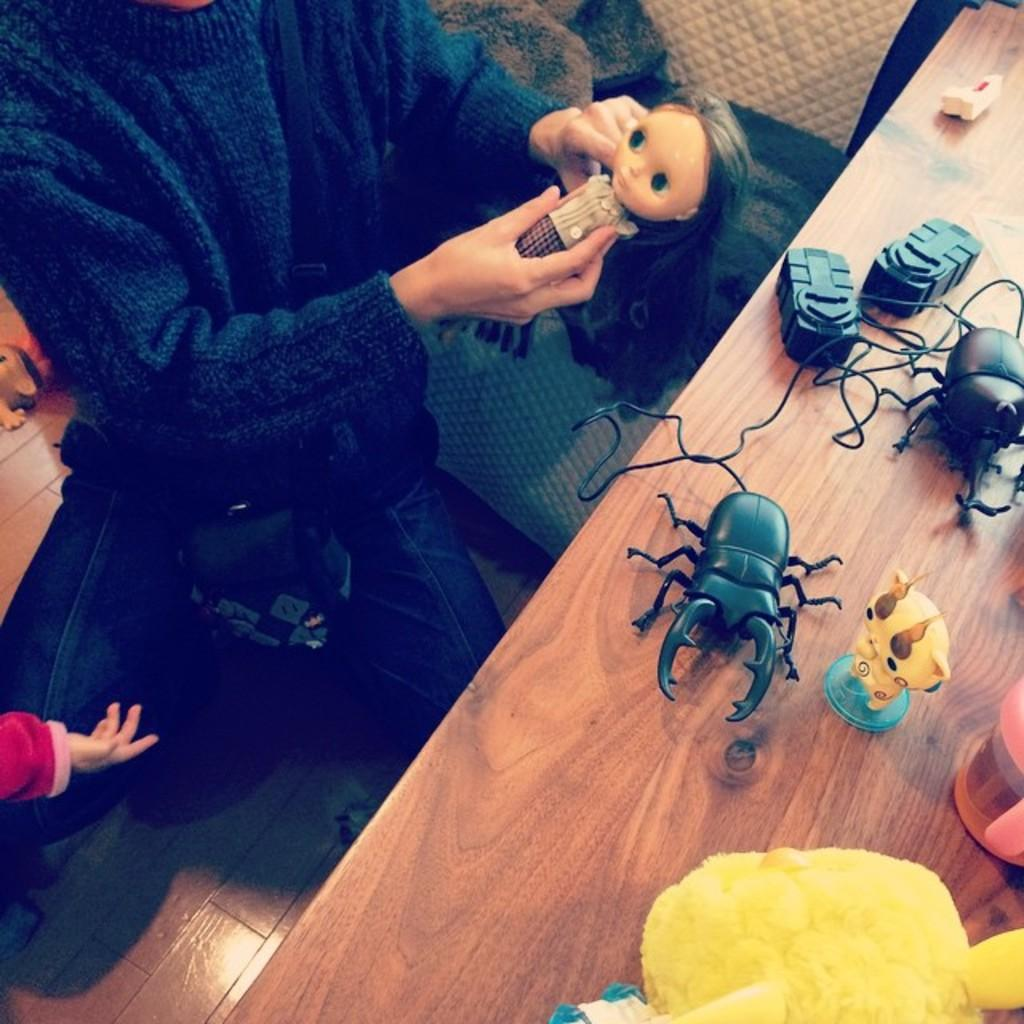What is the person in the image holding? The person is holding a doll in the image. What can be seen on the floor in the image? There are toys and other objects on the floor in the image. What is on the table in the image? There are toys, a cup, and other objects on the table in the image. Can you describe the toys on the table? There are insect toys on the table in the image. What type of mine is visible in the image? There is no mine present in the image. Can you tell me how many zebras are playing volleyball in the image? There are no zebras or volleyball games present in the image. 